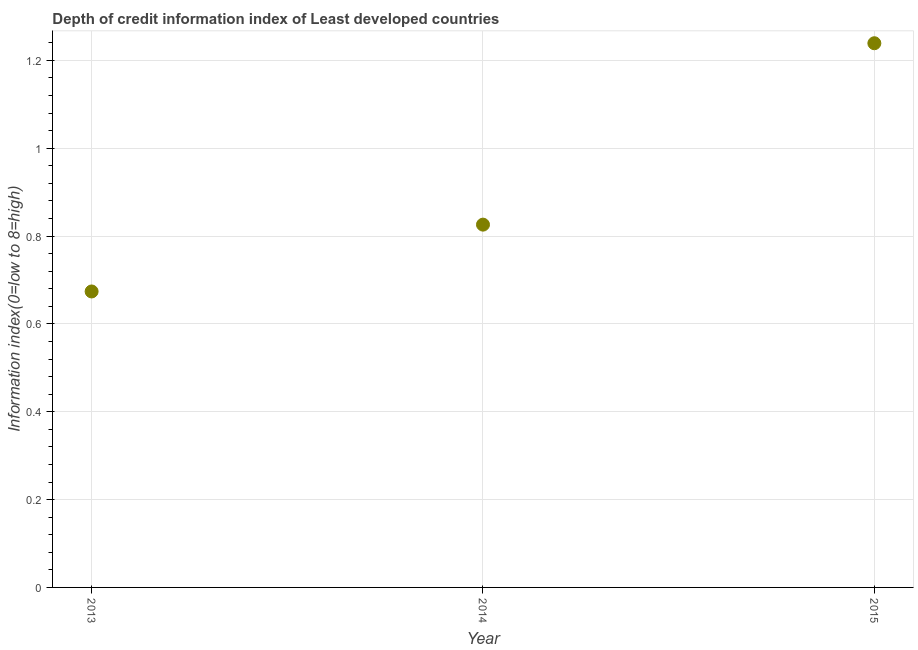What is the depth of credit information index in 2015?
Make the answer very short. 1.24. Across all years, what is the maximum depth of credit information index?
Provide a succinct answer. 1.24. Across all years, what is the minimum depth of credit information index?
Offer a terse response. 0.67. In which year was the depth of credit information index maximum?
Give a very brief answer. 2015. In which year was the depth of credit information index minimum?
Ensure brevity in your answer.  2013. What is the sum of the depth of credit information index?
Make the answer very short. 2.74. What is the difference between the depth of credit information index in 2014 and 2015?
Your response must be concise. -0.41. What is the average depth of credit information index per year?
Offer a terse response. 0.91. What is the median depth of credit information index?
Provide a succinct answer. 0.83. In how many years, is the depth of credit information index greater than 0.8400000000000001 ?
Offer a terse response. 1. What is the ratio of the depth of credit information index in 2014 to that in 2015?
Make the answer very short. 0.67. Is the depth of credit information index in 2014 less than that in 2015?
Provide a short and direct response. Yes. Is the difference between the depth of credit information index in 2013 and 2014 greater than the difference between any two years?
Your answer should be compact. No. What is the difference between the highest and the second highest depth of credit information index?
Your answer should be compact. 0.41. What is the difference between the highest and the lowest depth of credit information index?
Your answer should be very brief. 0.57. Does the depth of credit information index monotonically increase over the years?
Make the answer very short. Yes. How many dotlines are there?
Provide a short and direct response. 1. Does the graph contain grids?
Give a very brief answer. Yes. What is the title of the graph?
Give a very brief answer. Depth of credit information index of Least developed countries. What is the label or title of the Y-axis?
Provide a succinct answer. Information index(0=low to 8=high). What is the Information index(0=low to 8=high) in 2013?
Offer a very short reply. 0.67. What is the Information index(0=low to 8=high) in 2014?
Ensure brevity in your answer.  0.83. What is the Information index(0=low to 8=high) in 2015?
Offer a terse response. 1.24. What is the difference between the Information index(0=low to 8=high) in 2013 and 2014?
Make the answer very short. -0.15. What is the difference between the Information index(0=low to 8=high) in 2013 and 2015?
Give a very brief answer. -0.57. What is the difference between the Information index(0=low to 8=high) in 2014 and 2015?
Provide a succinct answer. -0.41. What is the ratio of the Information index(0=low to 8=high) in 2013 to that in 2014?
Make the answer very short. 0.82. What is the ratio of the Information index(0=low to 8=high) in 2013 to that in 2015?
Make the answer very short. 0.54. What is the ratio of the Information index(0=low to 8=high) in 2014 to that in 2015?
Provide a short and direct response. 0.67. 